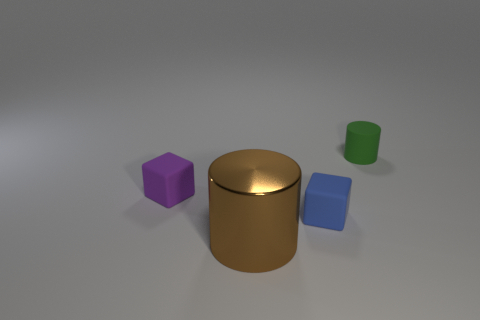Is there anything else that has the same size as the metal cylinder?
Your answer should be compact. No. What color is the metallic cylinder?
Your response must be concise. Brown. Does the tiny object right of the blue matte cube have the same shape as the large brown thing?
Offer a terse response. Yes. Are there fewer purple cubes that are to the left of the small purple rubber block than big brown cylinders behind the small matte cylinder?
Provide a short and direct response. No. What material is the cube that is in front of the purple rubber cube?
Give a very brief answer. Rubber. Are there any green cylinders of the same size as the purple rubber block?
Make the answer very short. Yes. Is the shape of the large thing the same as the tiny rubber thing that is to the right of the small blue rubber thing?
Offer a very short reply. Yes. Does the matte cube that is on the right side of the large brown cylinder have the same size as the thing behind the purple block?
Make the answer very short. Yes. What is the material of the cylinder in front of the rubber block that is to the left of the large object?
Your answer should be very brief. Metal. What number of rubber things are brown objects or tiny green cubes?
Your answer should be compact. 0. 